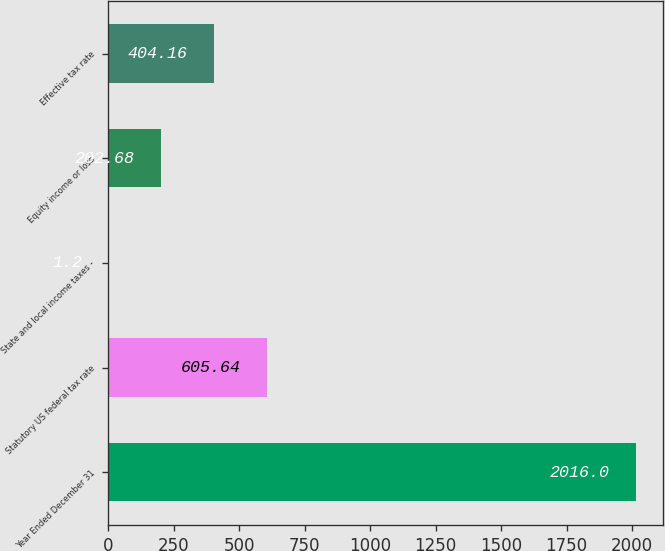Convert chart to OTSL. <chart><loc_0><loc_0><loc_500><loc_500><bar_chart><fcel>Year Ended December 31<fcel>Statutory US federal tax rate<fcel>State and local income taxes -<fcel>Equity income or loss<fcel>Effective tax rate<nl><fcel>2016<fcel>605.64<fcel>1.2<fcel>202.68<fcel>404.16<nl></chart> 